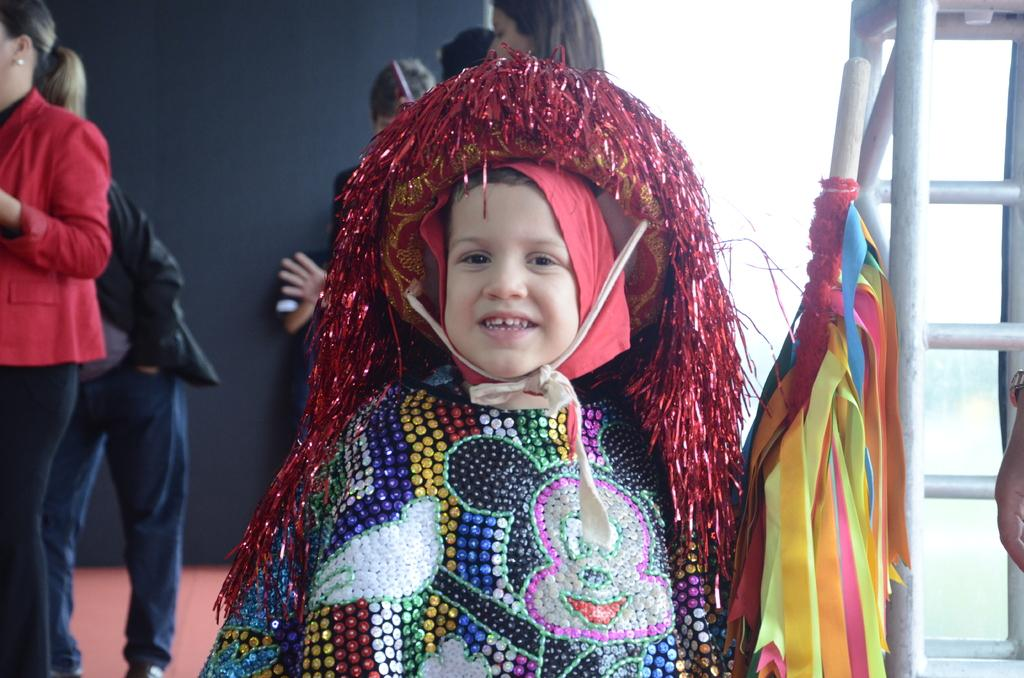How many people are in the image? There are persons in the image, but the exact number is not specified. Can you describe the age of one of the persons? One of the persons is a kid. What are the people in the image wearing? The kid is wearing the same dress as others. What type of hammer is the kid holding in the image? There is no hammer present in the image. Can you describe the sail on the boat in the image? There is no boat or sail present in the image. 